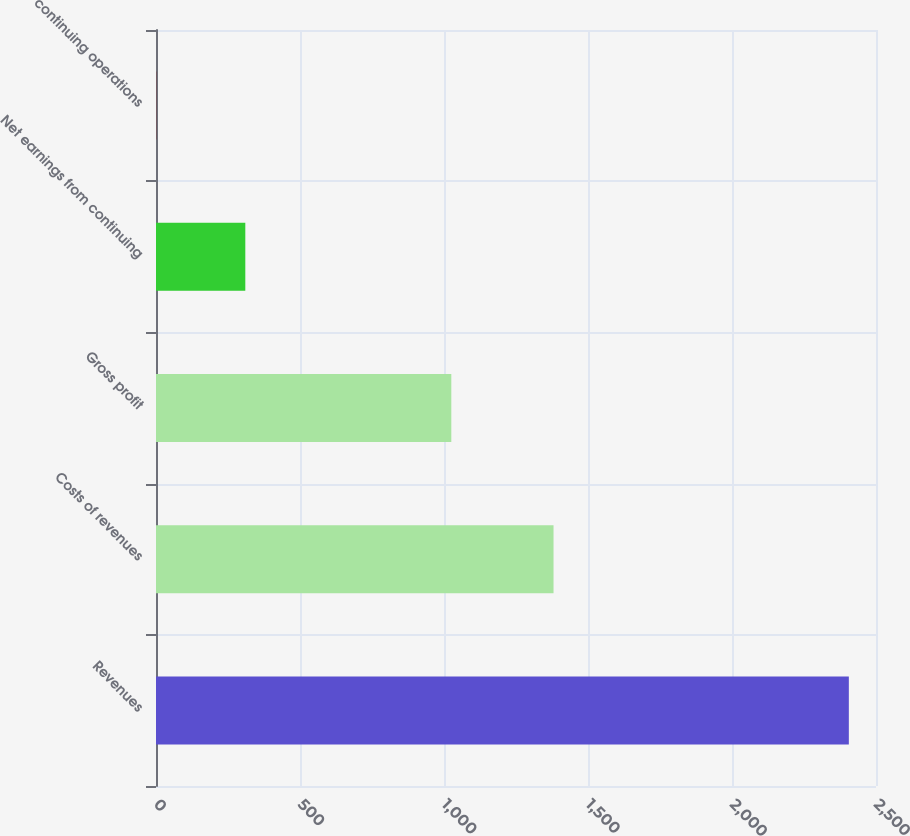Convert chart to OTSL. <chart><loc_0><loc_0><loc_500><loc_500><bar_chart><fcel>Revenues<fcel>Costs of revenues<fcel>Gross profit<fcel>Net earnings from continuing<fcel>continuing operations<nl><fcel>2405.7<fcel>1380.3<fcel>1025.4<fcel>310.1<fcel>0.63<nl></chart> 